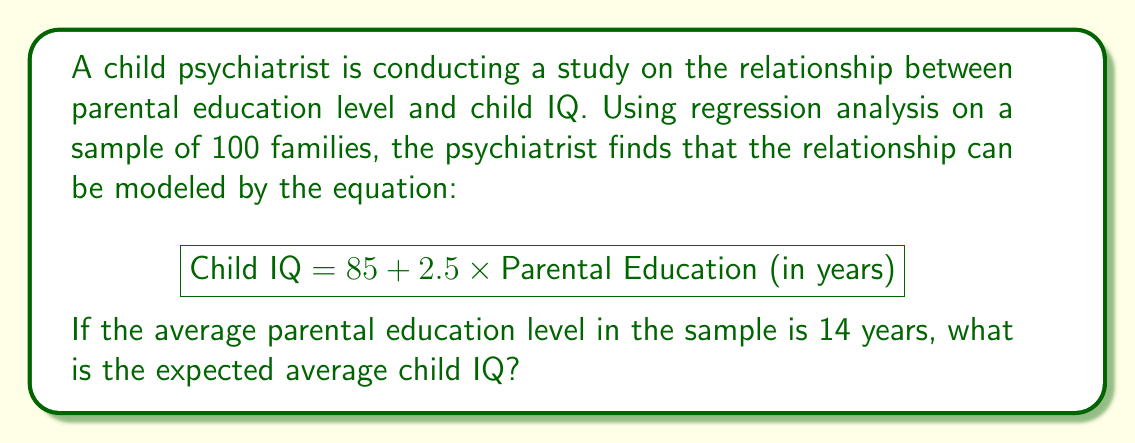Could you help me with this problem? To solve this problem, we'll follow these steps:

1. Identify the given information:
   - Regression equation: $\text{Child IQ} = 85 + 2.5 \times \text{Parental Education (in years)}$
   - Average parental education level: 14 years

2. Substitute the average parental education level into the equation:
   $\text{Child IQ} = 85 + 2.5 \times 14$

3. Perform the multiplication:
   $\text{Child IQ} = 85 + 35$

4. Add the results:
   $\text{Child IQ} = 120$

Therefore, based on the regression analysis, the expected average child IQ for families with an average parental education level of 14 years is 120.
Answer: 120 